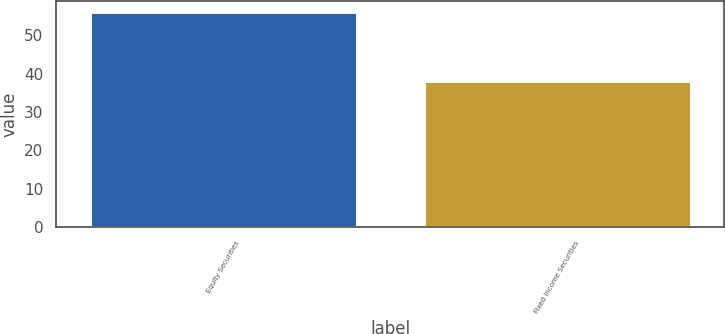Convert chart to OTSL. <chart><loc_0><loc_0><loc_500><loc_500><bar_chart><fcel>Equity Securities<fcel>Fixed Income Securities<nl><fcel>56<fcel>38<nl></chart> 